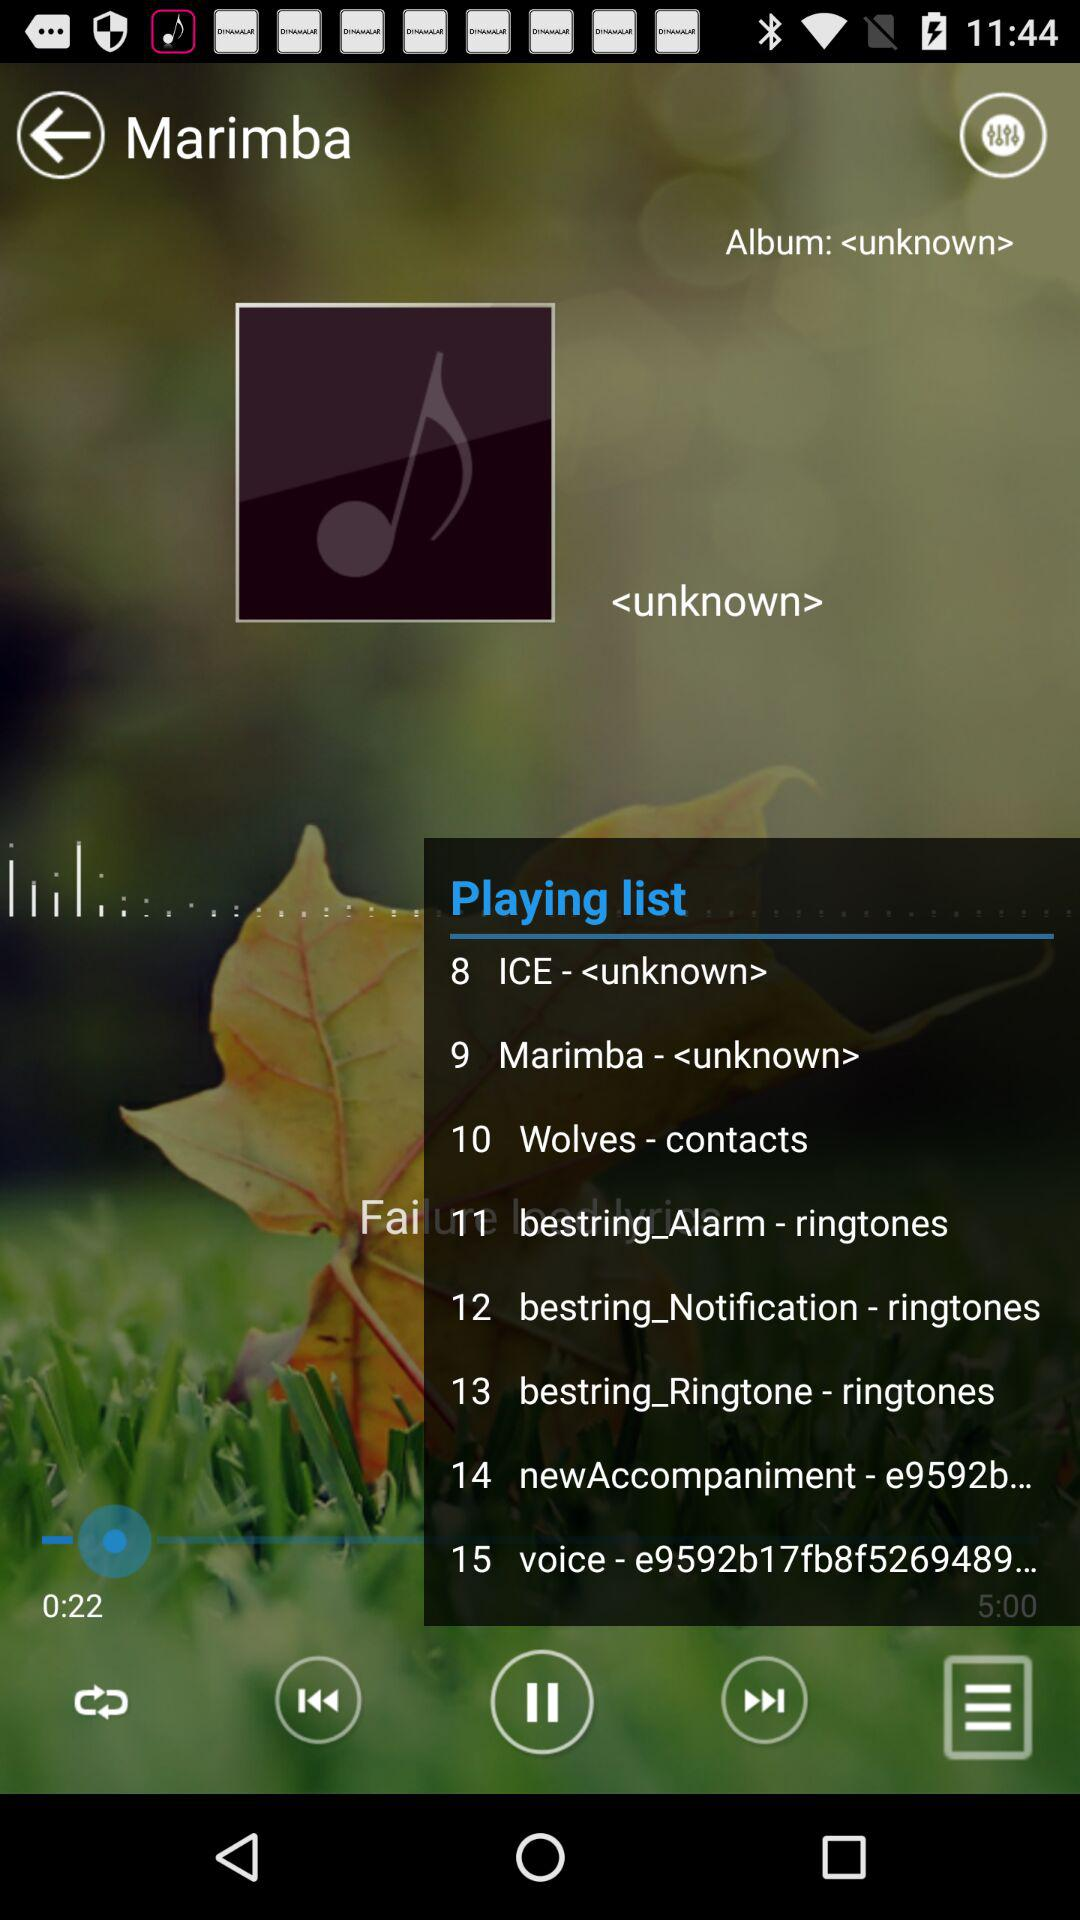What is the total duration? The total duration is 5 minutes. 